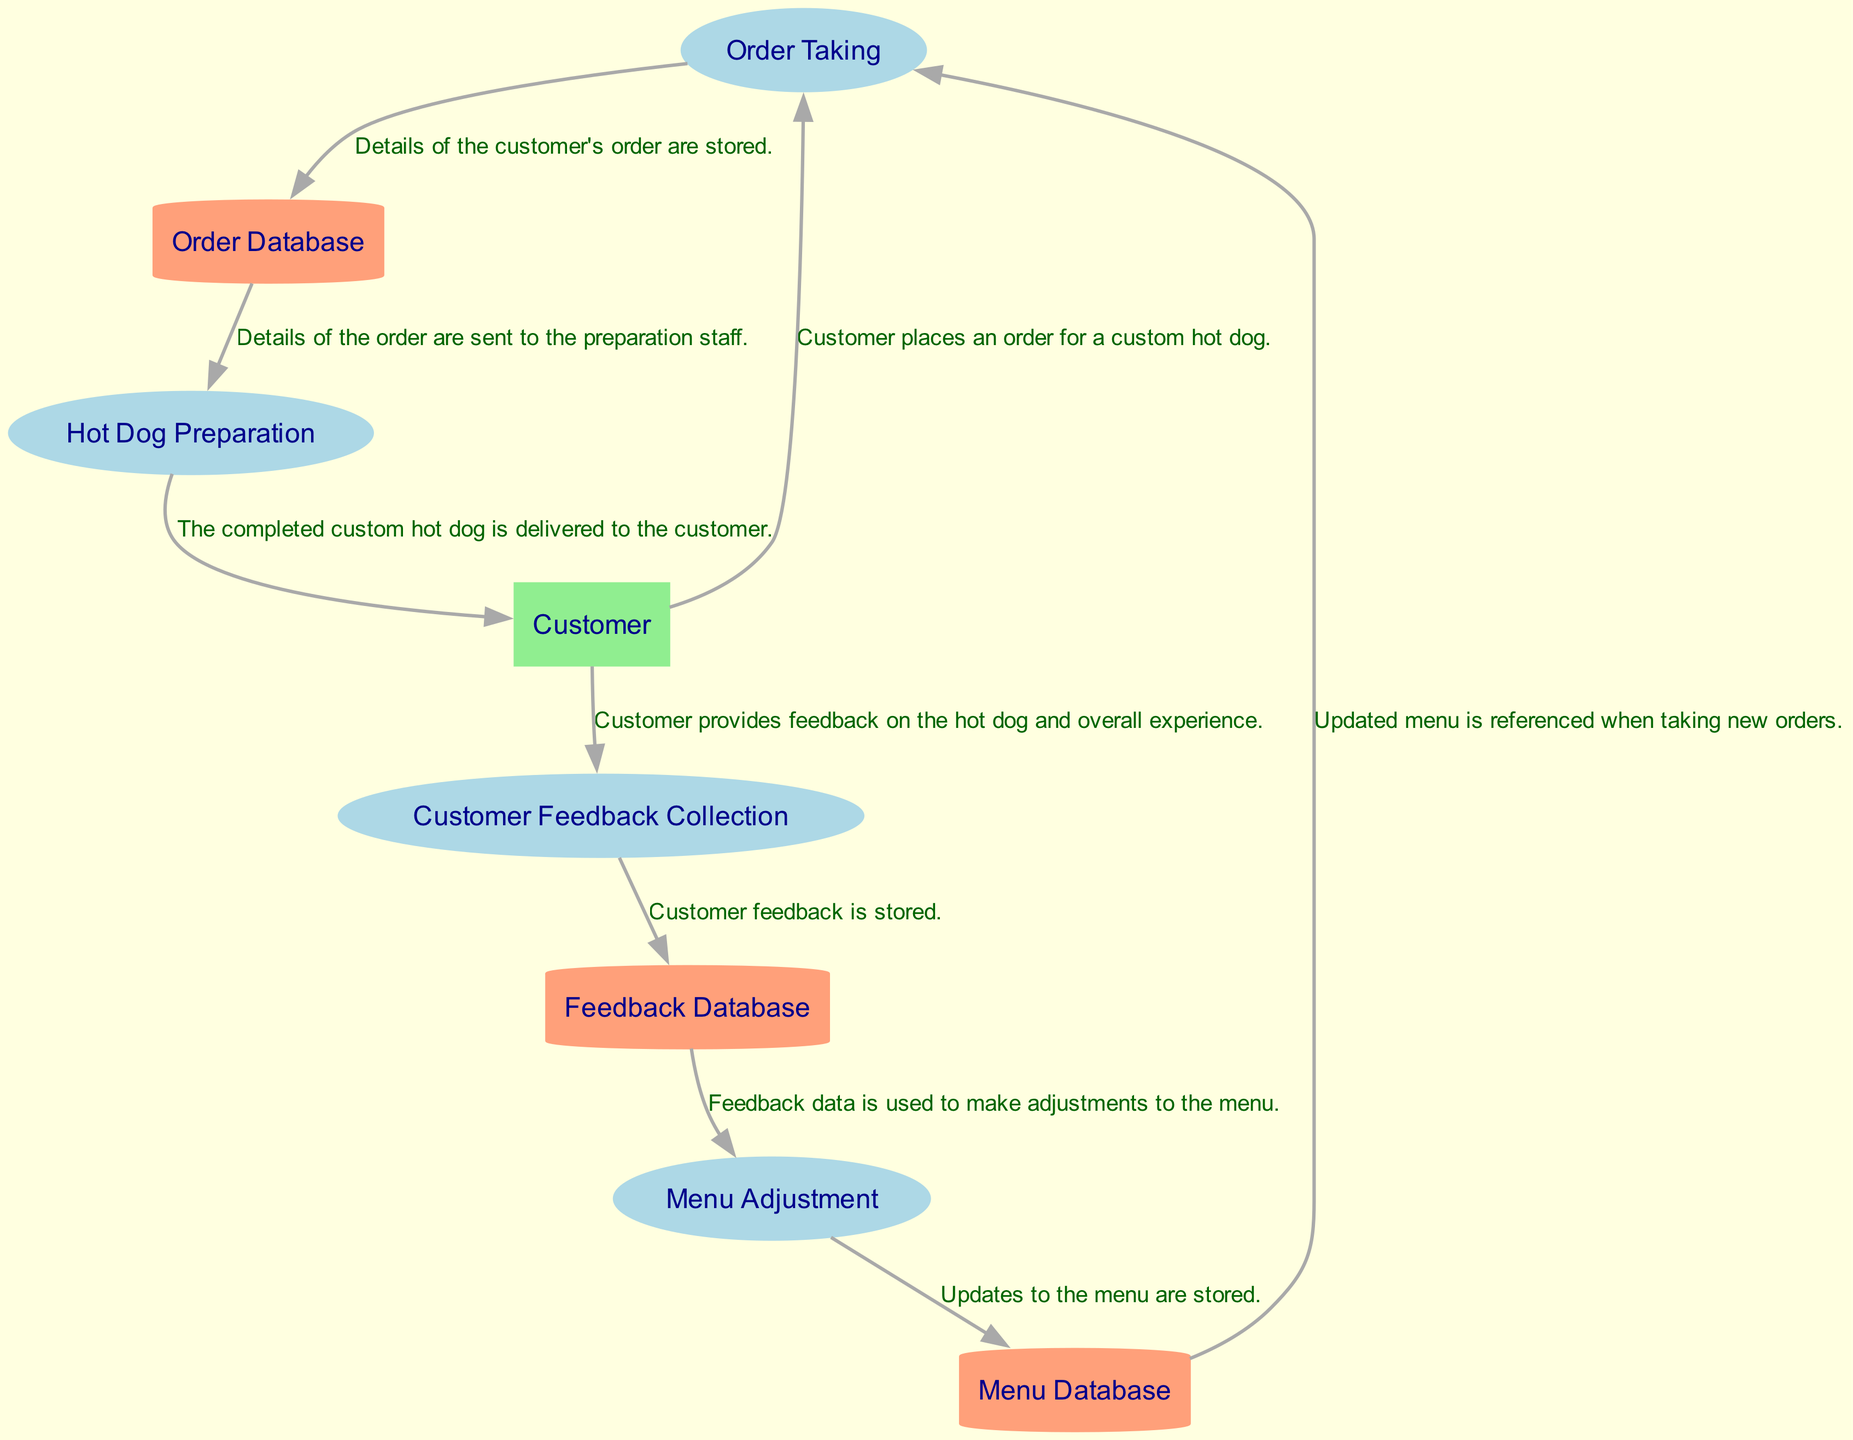What is the first process in the diagram? The diagram identifies the first process by the order in which the processes are listed, which begins with "Order Taking."
Answer: Order Taking How many external entities are present in the diagram? The diagram reveals that there is one external entity labeled as "Customer."
Answer: 1 What type of node is used to represent the "Order Database"? The "Order Database" is represented as a cylindrical node, which is characteristic of data store nodes in a data flow diagram.
Answer: Cylinder What flow comes from "Customer Feedback Collection" to "Feedback Database"? The flow from "Customer Feedback Collection" to "Feedback Database" is labeled with the description "Customer feedback is stored."
Answer: Customer feedback is stored Which process uses customer feedback to make changes? The process that uses customer feedback to make changes is called "Menu Adjustment," as highlighted in the data flow from the "Feedback Database."
Answer: Menu Adjustment How many processes are shown in the diagram? The diagram lists a total of four distinct processes outlined, namely "Order Taking," "Hot Dog Preparation," "Customer Feedback Collection," and "Menu Adjustment."
Answer: 4 What is the relationship between "Menu Adjustment" and "Menu Database"? The relationship between "Menu Adjustment" and "Menu Database" is indicated by the flow "Updates to the menu are stored," which shows that this process updates the menu database.
Answer: Updates to the menu are stored From which process does the "Hot Dog Preparation" receive order details? The "Hot Dog Preparation" receives order details from the "Order Database," as indicated by the data flow between these two nodes in the diagram.
Answer: Order Database What does the "Customer" provide after receiving their hot dog? After receiving their hot dog, the "Customer" provides feedback through the "Customer Feedback Collection" process, showcasing their experience with the product.
Answer: Feedback 